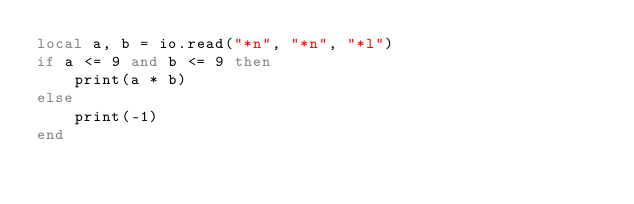<code> <loc_0><loc_0><loc_500><loc_500><_Lua_>local a, b = io.read("*n", "*n", "*l")
if a <= 9 and b <= 9 then
	print(a * b)
else
	print(-1)
end
</code> 